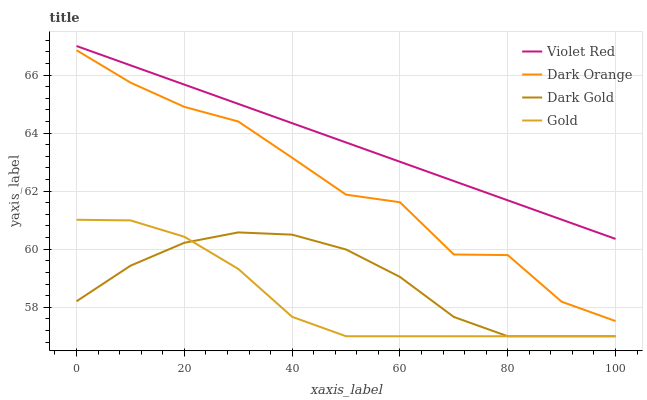Does Violet Red have the minimum area under the curve?
Answer yes or no. No. Does Gold have the maximum area under the curve?
Answer yes or no. No. Is Gold the smoothest?
Answer yes or no. No. Is Gold the roughest?
Answer yes or no. No. Does Violet Red have the lowest value?
Answer yes or no. No. Does Gold have the highest value?
Answer yes or no. No. Is Dark Gold less than Dark Orange?
Answer yes or no. Yes. Is Dark Orange greater than Gold?
Answer yes or no. Yes. Does Dark Gold intersect Dark Orange?
Answer yes or no. No. 